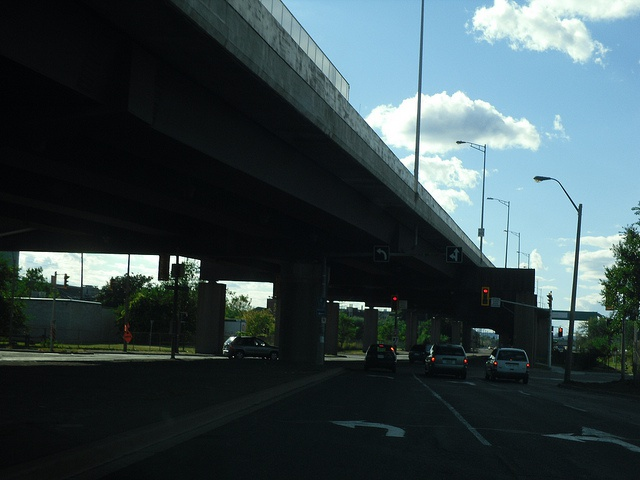Describe the objects in this image and their specific colors. I can see car in black, purple, darkblue, and teal tones, car in black, purple, darkblue, and teal tones, car in black, gray, ivory, and darkgray tones, car in black, gray, darkgreen, and purple tones, and car in black, darkblue, and purple tones in this image. 